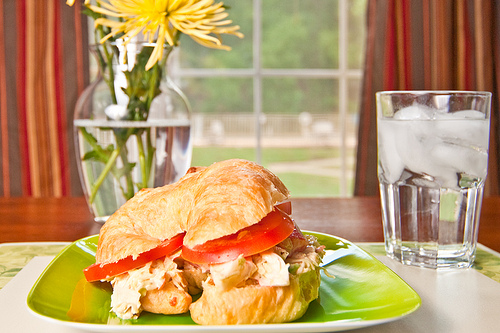What pastry is on the plate? The plate contains a croissant pastry. 